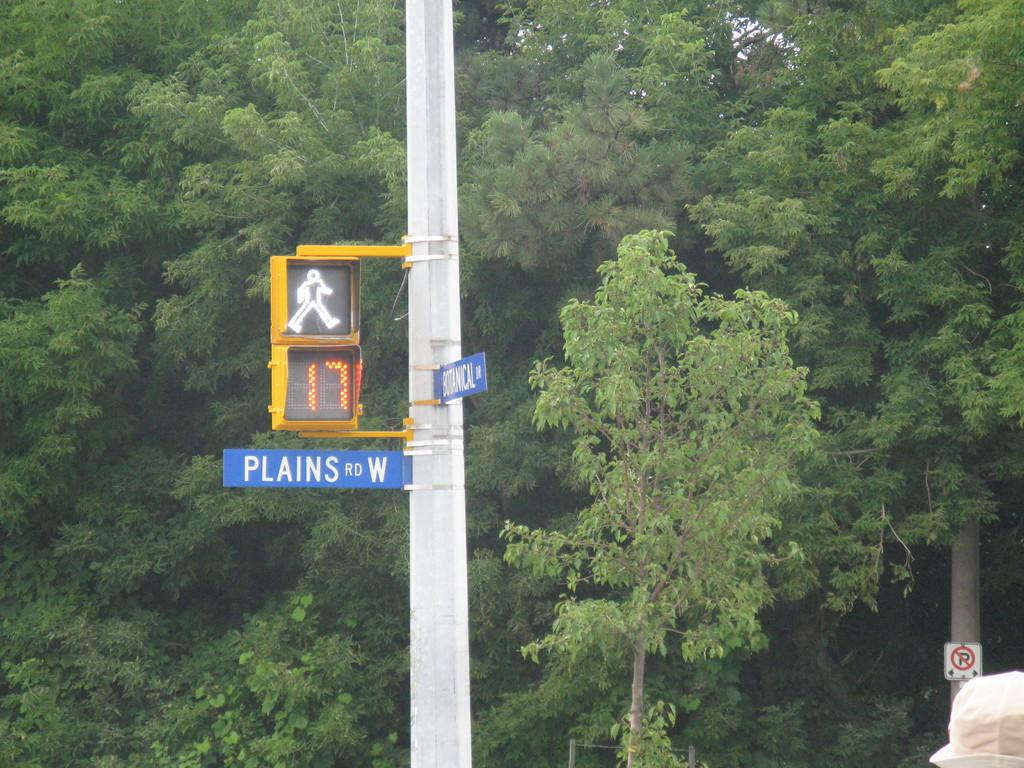What is the main object in the image? There is a name board in the image. What else can be seen attached to a pole in the image? There is a traffic signal attached to a pole in the image. What other sign is present in the image? There is a signboard in the image. What type of accessory is visible in the image? There is a cap in the image. What can be seen in the distance in the image? There are trees visible in the background of the image. What color is the ink on the son's wish in the image? There is no mention of ink, a son, or a wish in the image; the image only contains a name board, traffic signal, signboard, cap, and trees in the background. 